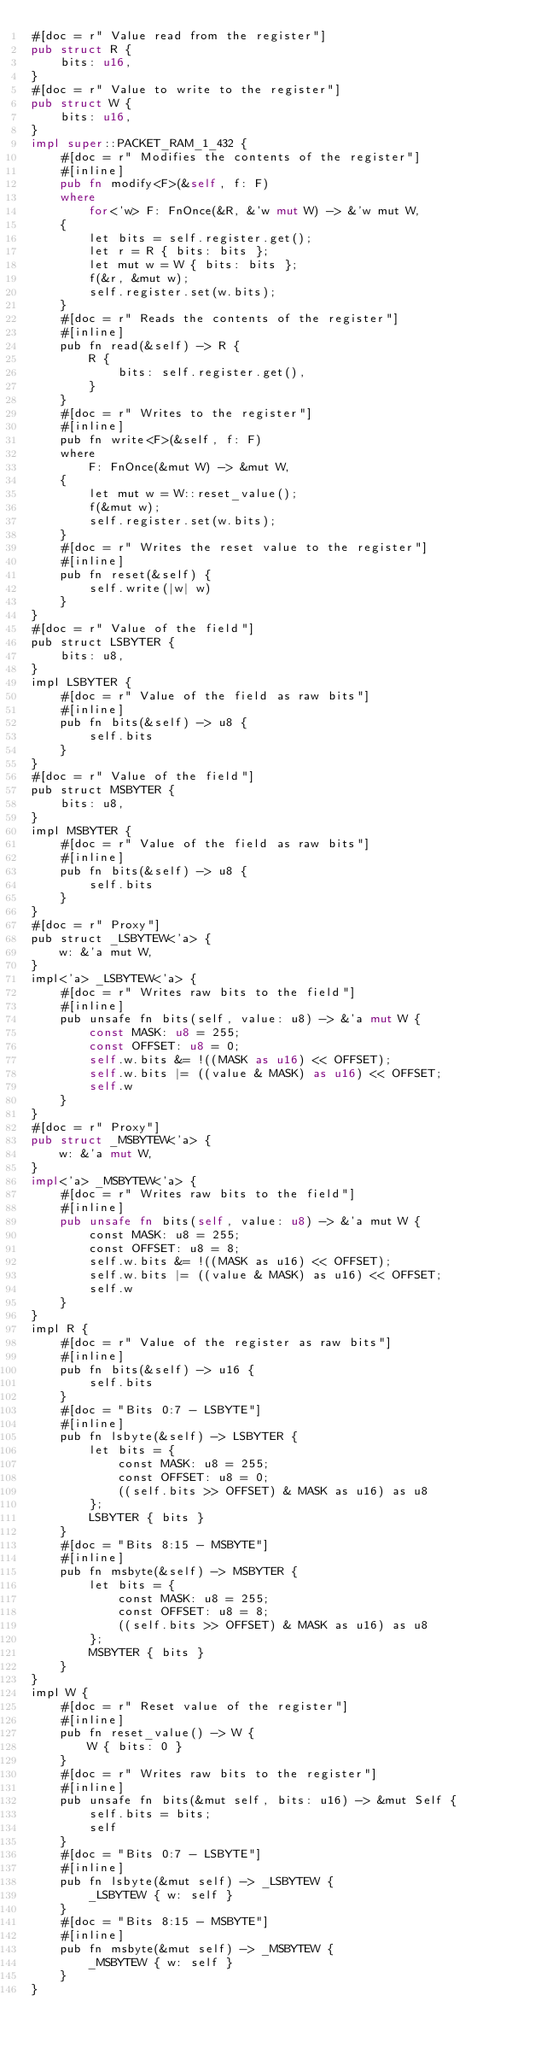<code> <loc_0><loc_0><loc_500><loc_500><_Rust_>#[doc = r" Value read from the register"]
pub struct R {
    bits: u16,
}
#[doc = r" Value to write to the register"]
pub struct W {
    bits: u16,
}
impl super::PACKET_RAM_1_432 {
    #[doc = r" Modifies the contents of the register"]
    #[inline]
    pub fn modify<F>(&self, f: F)
    where
        for<'w> F: FnOnce(&R, &'w mut W) -> &'w mut W,
    {
        let bits = self.register.get();
        let r = R { bits: bits };
        let mut w = W { bits: bits };
        f(&r, &mut w);
        self.register.set(w.bits);
    }
    #[doc = r" Reads the contents of the register"]
    #[inline]
    pub fn read(&self) -> R {
        R {
            bits: self.register.get(),
        }
    }
    #[doc = r" Writes to the register"]
    #[inline]
    pub fn write<F>(&self, f: F)
    where
        F: FnOnce(&mut W) -> &mut W,
    {
        let mut w = W::reset_value();
        f(&mut w);
        self.register.set(w.bits);
    }
    #[doc = r" Writes the reset value to the register"]
    #[inline]
    pub fn reset(&self) {
        self.write(|w| w)
    }
}
#[doc = r" Value of the field"]
pub struct LSBYTER {
    bits: u8,
}
impl LSBYTER {
    #[doc = r" Value of the field as raw bits"]
    #[inline]
    pub fn bits(&self) -> u8 {
        self.bits
    }
}
#[doc = r" Value of the field"]
pub struct MSBYTER {
    bits: u8,
}
impl MSBYTER {
    #[doc = r" Value of the field as raw bits"]
    #[inline]
    pub fn bits(&self) -> u8 {
        self.bits
    }
}
#[doc = r" Proxy"]
pub struct _LSBYTEW<'a> {
    w: &'a mut W,
}
impl<'a> _LSBYTEW<'a> {
    #[doc = r" Writes raw bits to the field"]
    #[inline]
    pub unsafe fn bits(self, value: u8) -> &'a mut W {
        const MASK: u8 = 255;
        const OFFSET: u8 = 0;
        self.w.bits &= !((MASK as u16) << OFFSET);
        self.w.bits |= ((value & MASK) as u16) << OFFSET;
        self.w
    }
}
#[doc = r" Proxy"]
pub struct _MSBYTEW<'a> {
    w: &'a mut W,
}
impl<'a> _MSBYTEW<'a> {
    #[doc = r" Writes raw bits to the field"]
    #[inline]
    pub unsafe fn bits(self, value: u8) -> &'a mut W {
        const MASK: u8 = 255;
        const OFFSET: u8 = 8;
        self.w.bits &= !((MASK as u16) << OFFSET);
        self.w.bits |= ((value & MASK) as u16) << OFFSET;
        self.w
    }
}
impl R {
    #[doc = r" Value of the register as raw bits"]
    #[inline]
    pub fn bits(&self) -> u16 {
        self.bits
    }
    #[doc = "Bits 0:7 - LSBYTE"]
    #[inline]
    pub fn lsbyte(&self) -> LSBYTER {
        let bits = {
            const MASK: u8 = 255;
            const OFFSET: u8 = 0;
            ((self.bits >> OFFSET) & MASK as u16) as u8
        };
        LSBYTER { bits }
    }
    #[doc = "Bits 8:15 - MSBYTE"]
    #[inline]
    pub fn msbyte(&self) -> MSBYTER {
        let bits = {
            const MASK: u8 = 255;
            const OFFSET: u8 = 8;
            ((self.bits >> OFFSET) & MASK as u16) as u8
        };
        MSBYTER { bits }
    }
}
impl W {
    #[doc = r" Reset value of the register"]
    #[inline]
    pub fn reset_value() -> W {
        W { bits: 0 }
    }
    #[doc = r" Writes raw bits to the register"]
    #[inline]
    pub unsafe fn bits(&mut self, bits: u16) -> &mut Self {
        self.bits = bits;
        self
    }
    #[doc = "Bits 0:7 - LSBYTE"]
    #[inline]
    pub fn lsbyte(&mut self) -> _LSBYTEW {
        _LSBYTEW { w: self }
    }
    #[doc = "Bits 8:15 - MSBYTE"]
    #[inline]
    pub fn msbyte(&mut self) -> _MSBYTEW {
        _MSBYTEW { w: self }
    }
}
</code> 